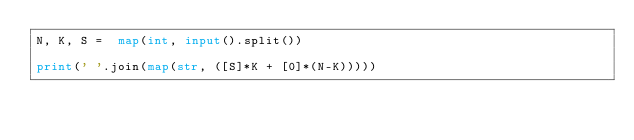Convert code to text. <code><loc_0><loc_0><loc_500><loc_500><_Python_>N, K, S =  map(int, input().split())

print(' '.join(map(str, ([S]*K + [0]*(N-K)))))</code> 